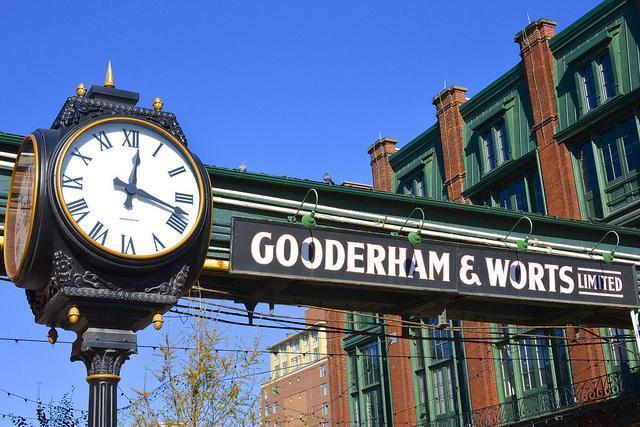How many clocks are in the photo?
Give a very brief answer. 2. 